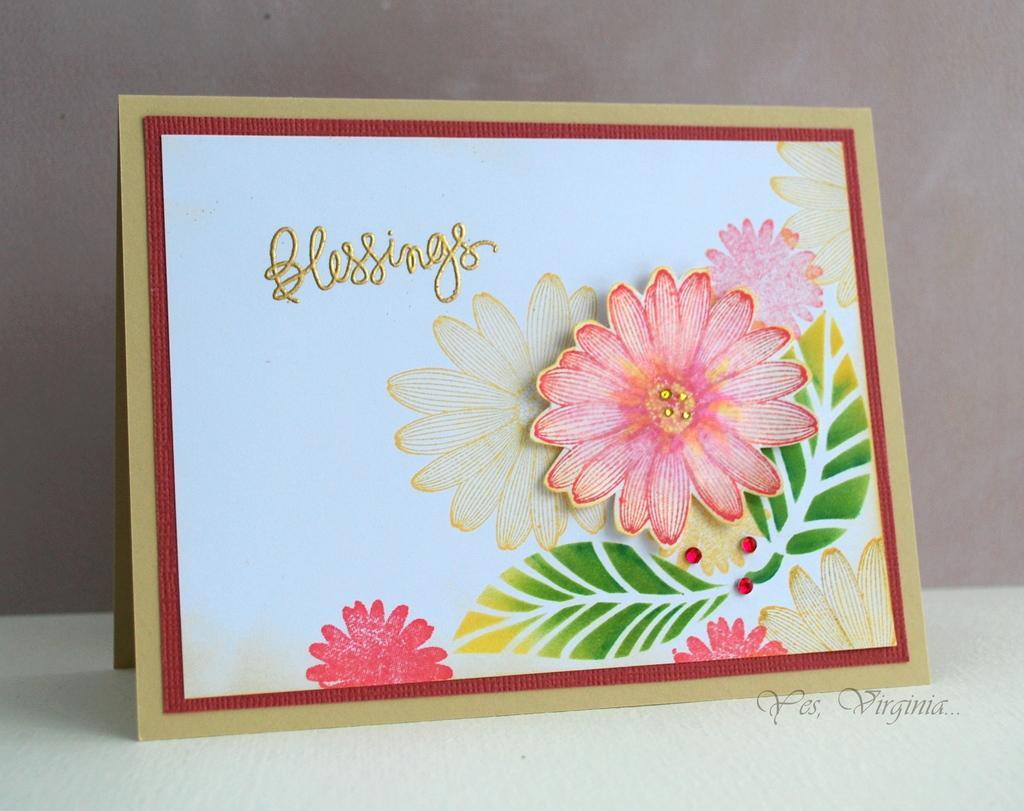Could you give a brief overview of what you see in this image? In the middle of this image, there is a greeting card having paintings of the flowers, a golden color text on a white color surface and a red color border. This greeting card is placed on a surface. On the bottom right, there is a watermark. And the background is gray in color. 